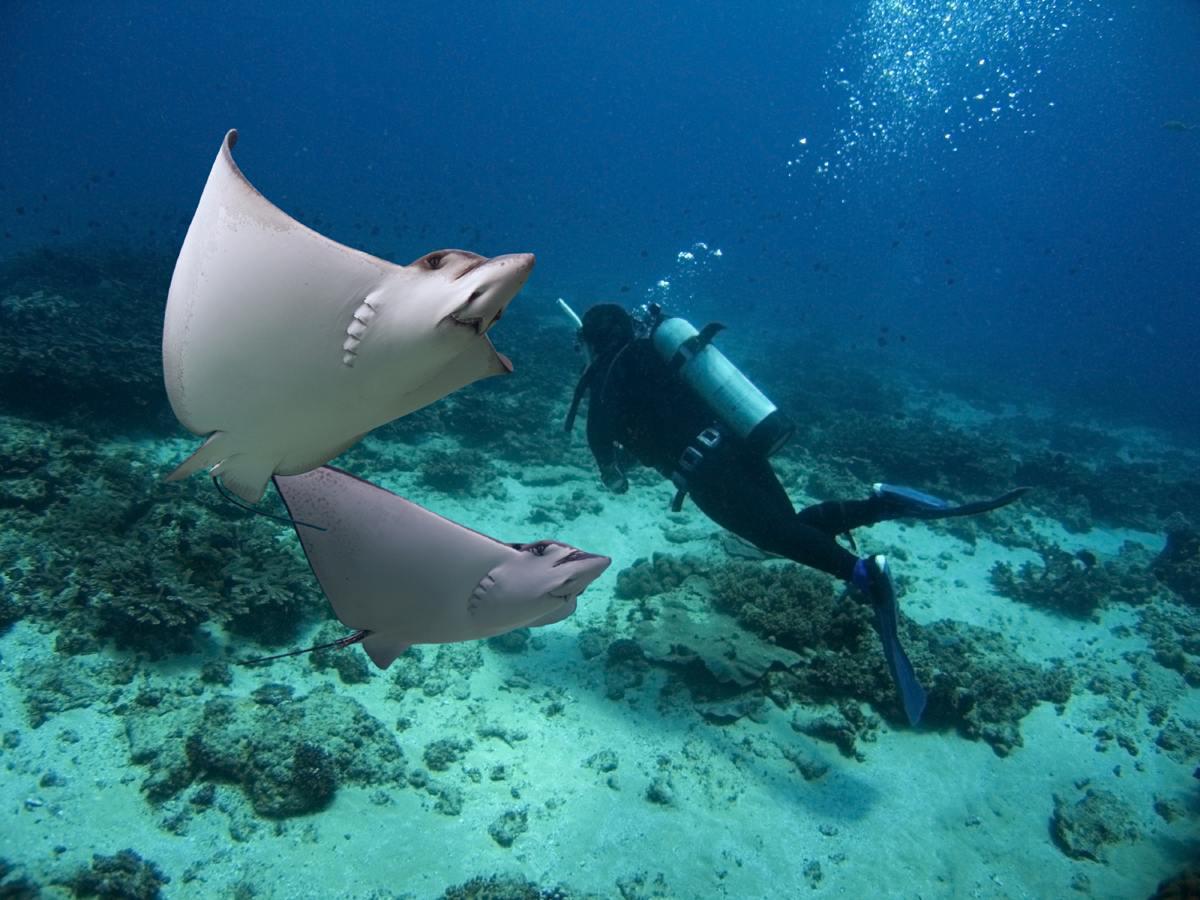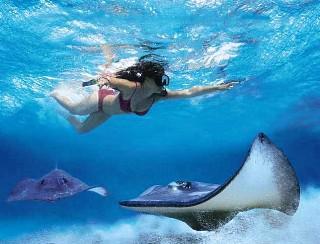The first image is the image on the left, the second image is the image on the right. Evaluate the accuracy of this statement regarding the images: "There is at least one person snorkeling in the water near one or more sting rays". Is it true? Answer yes or no. Yes. The first image is the image on the left, the second image is the image on the right. Analyze the images presented: Is the assertion "There is one human in the left image." valid? Answer yes or no. Yes. 